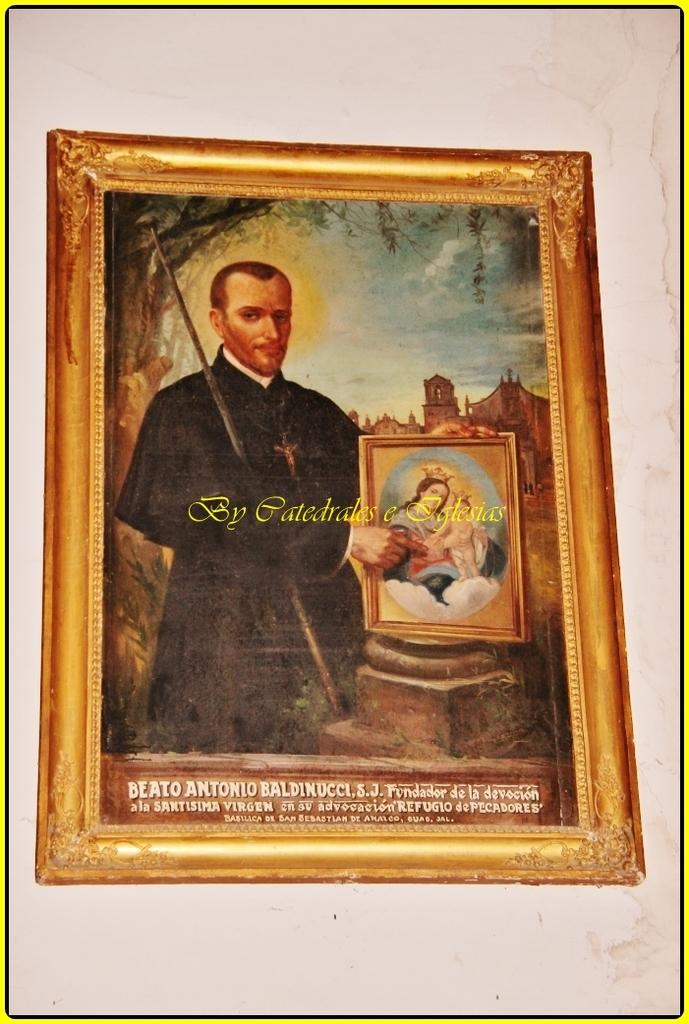<image>
Present a compact description of the photo's key features. a photo album that has Gatedrales on it 